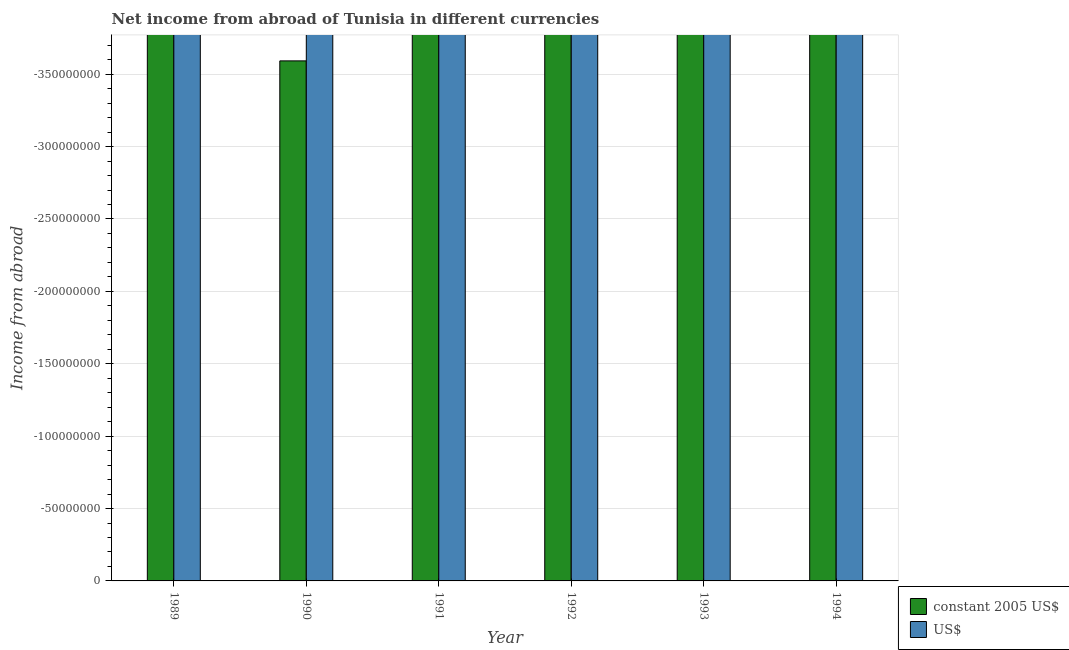How many different coloured bars are there?
Give a very brief answer. 0. Are the number of bars per tick equal to the number of legend labels?
Offer a very short reply. No. Are the number of bars on each tick of the X-axis equal?
Ensure brevity in your answer.  Yes. What is the label of the 6th group of bars from the left?
Provide a succinct answer. 1994. What is the total income from abroad in us$ in the graph?
Keep it short and to the point. 0. What is the difference between the income from abroad in constant 2005 us$ in 1994 and the income from abroad in us$ in 1990?
Keep it short and to the point. 0. In how many years, is the income from abroad in constant 2005 us$ greater than the average income from abroad in constant 2005 us$ taken over all years?
Provide a short and direct response. 0. How many bars are there?
Provide a short and direct response. 0. What is the difference between two consecutive major ticks on the Y-axis?
Make the answer very short. 5.00e+07. Does the graph contain any zero values?
Ensure brevity in your answer.  Yes. Where does the legend appear in the graph?
Your answer should be very brief. Bottom right. What is the title of the graph?
Offer a very short reply. Net income from abroad of Tunisia in different currencies. Does "Taxes on profits and capital gains" appear as one of the legend labels in the graph?
Ensure brevity in your answer.  No. What is the label or title of the X-axis?
Your answer should be compact. Year. What is the label or title of the Y-axis?
Keep it short and to the point. Income from abroad. What is the Income from abroad of constant 2005 US$ in 1989?
Your response must be concise. 0. What is the Income from abroad of US$ in 1989?
Keep it short and to the point. 0. What is the Income from abroad in US$ in 1990?
Offer a terse response. 0. What is the Income from abroad in constant 2005 US$ in 1991?
Your answer should be very brief. 0. What is the Income from abroad in US$ in 1991?
Provide a succinct answer. 0. What is the Income from abroad of US$ in 1992?
Give a very brief answer. 0. What is the Income from abroad in constant 2005 US$ in 1993?
Your answer should be very brief. 0. What is the Income from abroad in US$ in 1993?
Offer a very short reply. 0. What is the Income from abroad of US$ in 1994?
Ensure brevity in your answer.  0. What is the average Income from abroad in constant 2005 US$ per year?
Provide a short and direct response. 0. 